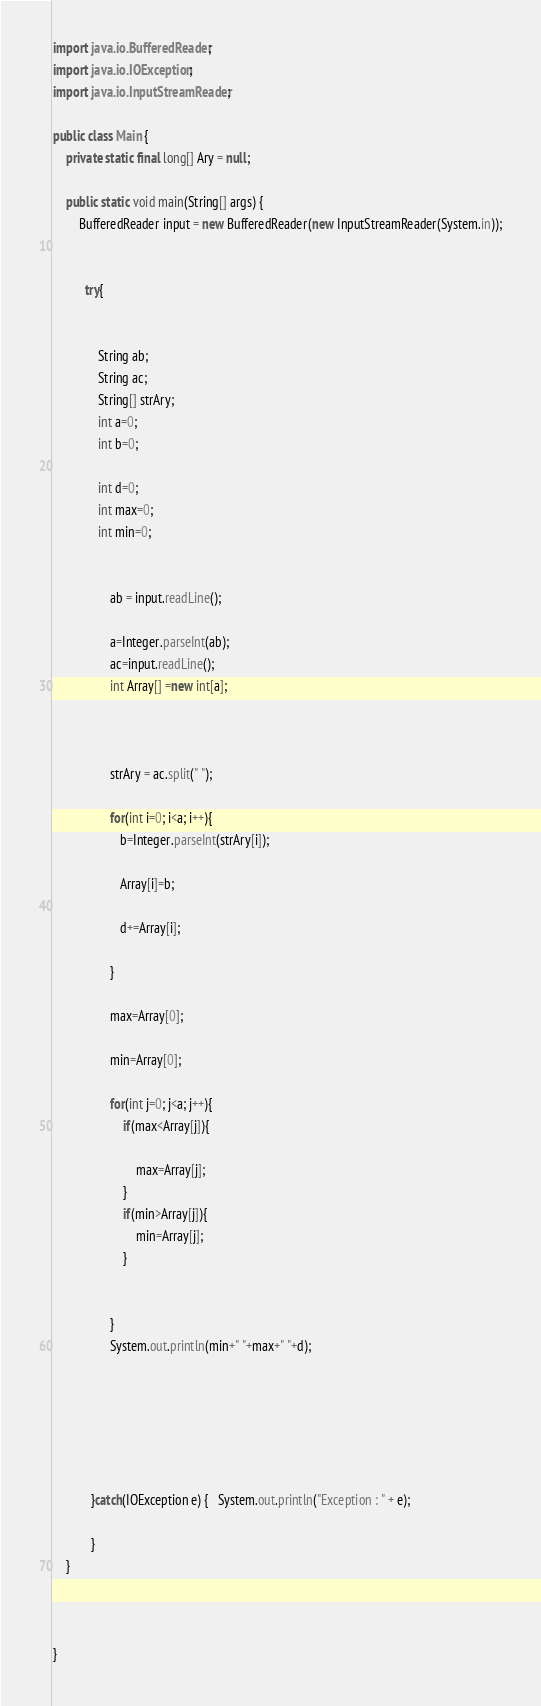Convert code to text. <code><loc_0><loc_0><loc_500><loc_500><_Java_>import java.io.BufferedReader;
import java.io.IOException;
import java.io.InputStreamReader;

public class Main {
	private static final long[] Ary = null;

	public static void main(String[] args) {
		BufferedReader input = new BufferedReader(new InputStreamReader(System.in));


		  try{


			  String ab;
			  String ac;
			  String[] strAry;
			  int a=0;
			  int b=0;

              int d=0;
              int max=0;
              int min=0;


			      ab = input.readLine();
			   
		          a=Integer.parseInt(ab);
		          ac=input.readLine();
		          int Array[] =new int[a];

		         
		       
		          strAry = ac.split(" ");
		       
		          for(int i=0; i<a; i++){
	                 b=Integer.parseInt(strAry[i]);
	               
	                 Array[i]=b;
	               
	                 d+=Array[i];
	                 
		          }

		          max=Array[0];
		        
		          min=Array[0];

		          for(int j=0; j<a; j++){
		        	  if(max<Array[j]){
		        		
		        		  max=Array[j];
		        	  }
		        	  if(min>Array[j]){
		        		  min=Array[j];
		        	  }


		          }
		          System.out.println(min+" "+max+" "+d);






		    }catch(IOException e) {   System.out.println("Exception : " + e);

		    }
	}



}</code> 